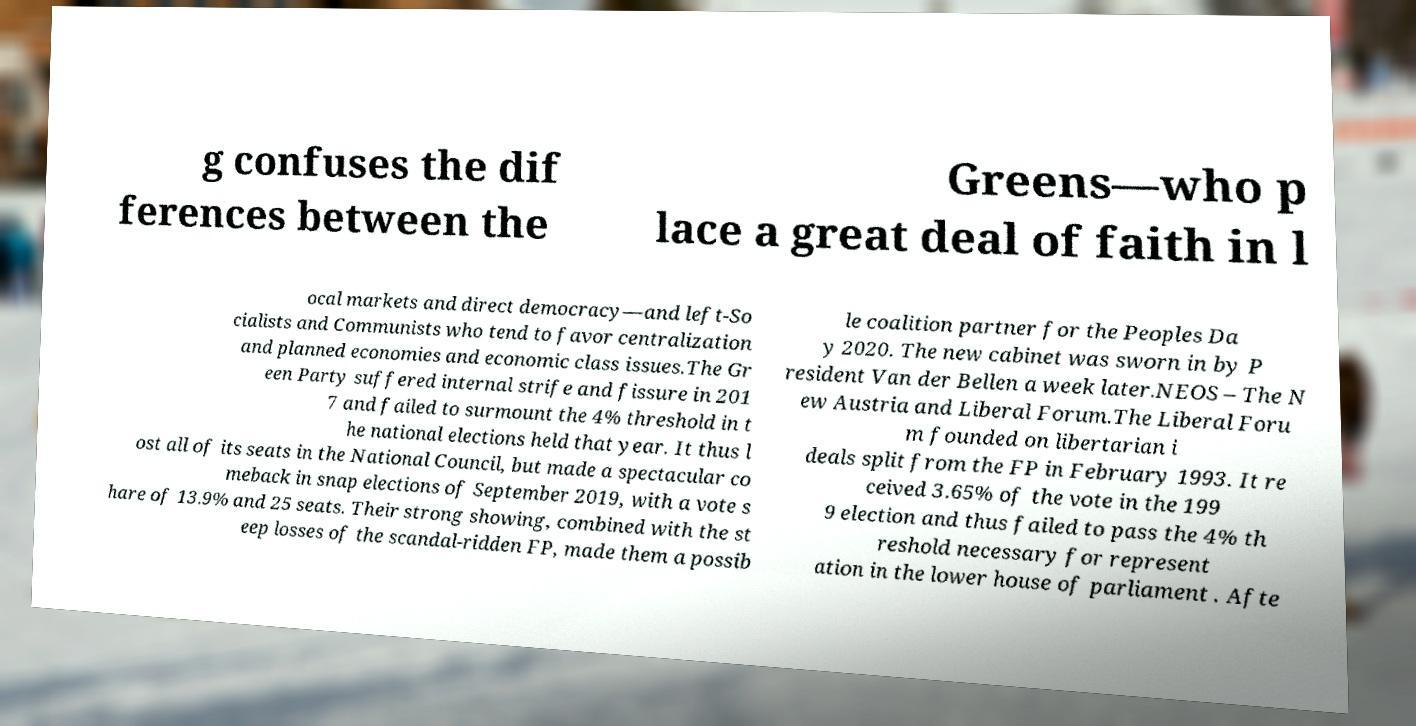What messages or text are displayed in this image? I need them in a readable, typed format. g confuses the dif ferences between the Greens—who p lace a great deal of faith in l ocal markets and direct democracy—and left-So cialists and Communists who tend to favor centralization and planned economies and economic class issues.The Gr een Party suffered internal strife and fissure in 201 7 and failed to surmount the 4% threshold in t he national elections held that year. It thus l ost all of its seats in the National Council, but made a spectacular co meback in snap elections of September 2019, with a vote s hare of 13.9% and 25 seats. Their strong showing, combined with the st eep losses of the scandal-ridden FP, made them a possib le coalition partner for the Peoples Da y 2020. The new cabinet was sworn in by P resident Van der Bellen a week later.NEOS – The N ew Austria and Liberal Forum.The Liberal Foru m founded on libertarian i deals split from the FP in February 1993. It re ceived 3.65% of the vote in the 199 9 election and thus failed to pass the 4% th reshold necessary for represent ation in the lower house of parliament . Afte 